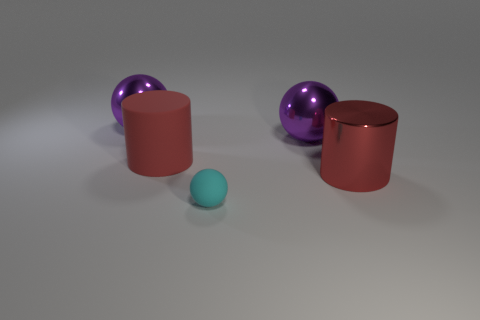How many other things are there of the same size as the shiny cylinder?
Make the answer very short. 3. There is a tiny thing that is in front of the cylinder that is on the right side of the rubber cylinder; what is its color?
Your answer should be compact. Cyan. What number of other objects are the same shape as the tiny rubber thing?
Your answer should be compact. 2. Is there a big cyan cylinder that has the same material as the tiny object?
Provide a succinct answer. No. There is another red cylinder that is the same size as the red matte cylinder; what is it made of?
Provide a succinct answer. Metal. There is a large metallic ball that is in front of the big purple metallic sphere behind the big purple ball that is on the right side of the red rubber object; what color is it?
Provide a succinct answer. Purple. Does the red thing that is left of the large red shiny object have the same shape as the purple metallic object that is to the right of the rubber ball?
Ensure brevity in your answer.  No. How many big purple shiny balls are there?
Offer a very short reply. 2. There is a matte thing that is the same size as the red metal cylinder; what is its color?
Your answer should be very brief. Red. Does the large red cylinder that is left of the tiny thing have the same material as the ball in front of the shiny cylinder?
Provide a succinct answer. Yes. 